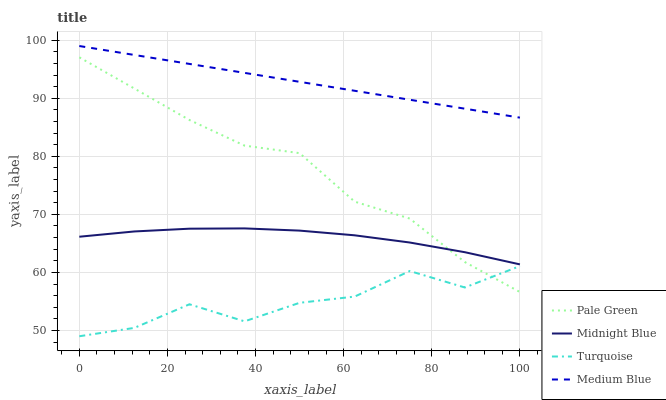Does Turquoise have the minimum area under the curve?
Answer yes or no. Yes. Does Medium Blue have the maximum area under the curve?
Answer yes or no. Yes. Does Pale Green have the minimum area under the curve?
Answer yes or no. No. Does Pale Green have the maximum area under the curve?
Answer yes or no. No. Is Medium Blue the smoothest?
Answer yes or no. Yes. Is Turquoise the roughest?
Answer yes or no. Yes. Is Pale Green the smoothest?
Answer yes or no. No. Is Pale Green the roughest?
Answer yes or no. No. Does Pale Green have the lowest value?
Answer yes or no. No. Does Medium Blue have the highest value?
Answer yes or no. Yes. Does Pale Green have the highest value?
Answer yes or no. No. Is Pale Green less than Medium Blue?
Answer yes or no. Yes. Is Medium Blue greater than Pale Green?
Answer yes or no. Yes. Does Turquoise intersect Pale Green?
Answer yes or no. Yes. Is Turquoise less than Pale Green?
Answer yes or no. No. Is Turquoise greater than Pale Green?
Answer yes or no. No. Does Pale Green intersect Medium Blue?
Answer yes or no. No. 